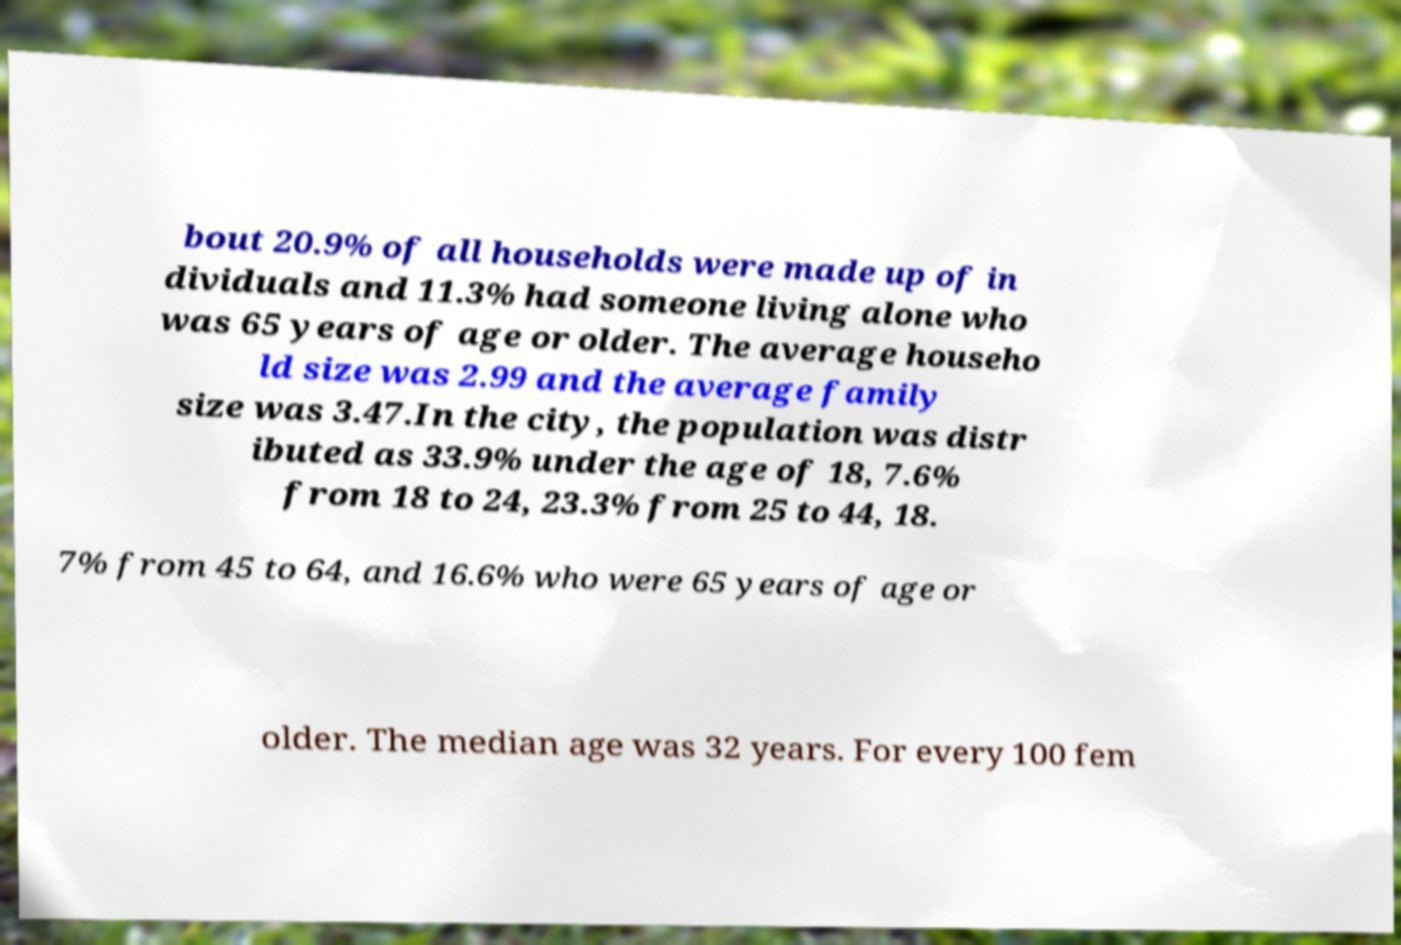Please identify and transcribe the text found in this image. bout 20.9% of all households were made up of in dividuals and 11.3% had someone living alone who was 65 years of age or older. The average househo ld size was 2.99 and the average family size was 3.47.In the city, the population was distr ibuted as 33.9% under the age of 18, 7.6% from 18 to 24, 23.3% from 25 to 44, 18. 7% from 45 to 64, and 16.6% who were 65 years of age or older. The median age was 32 years. For every 100 fem 